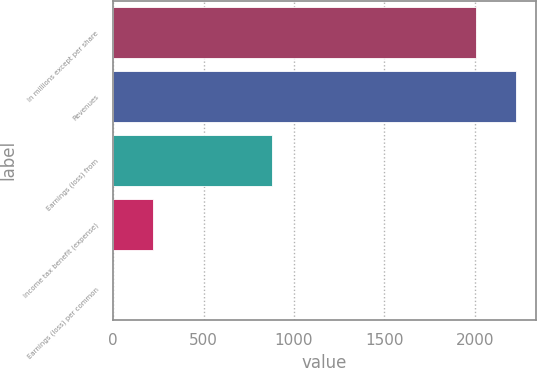Convert chart to OTSL. <chart><loc_0><loc_0><loc_500><loc_500><bar_chart><fcel>In millions except per share<fcel>Revenues<fcel>Earnings (loss) from<fcel>Income tax benefit (expense)<fcel>Earnings (loss) per common<nl><fcel>2006<fcel>2225.05<fcel>876.67<fcel>219.52<fcel>0.47<nl></chart> 